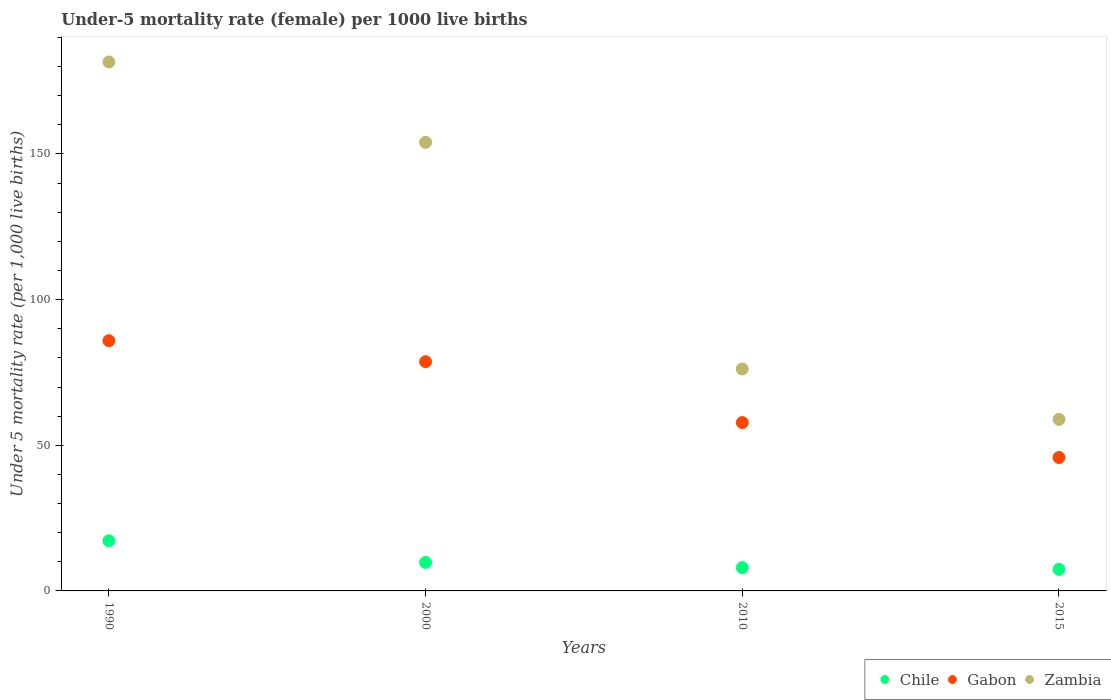How many different coloured dotlines are there?
Your answer should be very brief. 3. Is the number of dotlines equal to the number of legend labels?
Ensure brevity in your answer.  Yes. What is the under-five mortality rate in Gabon in 2015?
Make the answer very short. 45.8. Across all years, what is the maximum under-five mortality rate in Zambia?
Your response must be concise. 181.6. Across all years, what is the minimum under-five mortality rate in Chile?
Ensure brevity in your answer.  7.4. In which year was the under-five mortality rate in Zambia minimum?
Provide a succinct answer. 2015. What is the total under-five mortality rate in Gabon in the graph?
Provide a succinct answer. 268.2. What is the difference between the under-five mortality rate in Chile in 1990 and that in 2000?
Your answer should be compact. 7.4. What is the difference between the under-five mortality rate in Gabon in 2015 and the under-five mortality rate in Zambia in 1990?
Provide a short and direct response. -135.8. What is the average under-five mortality rate in Gabon per year?
Offer a very short reply. 67.05. In the year 2000, what is the difference between the under-five mortality rate in Chile and under-five mortality rate in Gabon?
Ensure brevity in your answer.  -68.9. What is the ratio of the under-five mortality rate in Chile in 2000 to that in 2015?
Ensure brevity in your answer.  1.32. Is the under-five mortality rate in Chile in 1990 less than that in 2015?
Ensure brevity in your answer.  No. What is the difference between the highest and the second highest under-five mortality rate in Gabon?
Make the answer very short. 7.2. What is the difference between the highest and the lowest under-five mortality rate in Zambia?
Provide a succinct answer. 122.7. Is the sum of the under-five mortality rate in Chile in 2000 and 2010 greater than the maximum under-five mortality rate in Gabon across all years?
Your answer should be compact. No. Is the under-five mortality rate in Zambia strictly less than the under-five mortality rate in Chile over the years?
Provide a succinct answer. No. What is the difference between two consecutive major ticks on the Y-axis?
Your answer should be compact. 50. Are the values on the major ticks of Y-axis written in scientific E-notation?
Provide a succinct answer. No. Does the graph contain any zero values?
Offer a very short reply. No. Does the graph contain grids?
Offer a very short reply. No. Where does the legend appear in the graph?
Give a very brief answer. Bottom right. How are the legend labels stacked?
Keep it short and to the point. Horizontal. What is the title of the graph?
Keep it short and to the point. Under-5 mortality rate (female) per 1000 live births. Does "Turkmenistan" appear as one of the legend labels in the graph?
Keep it short and to the point. No. What is the label or title of the Y-axis?
Your answer should be very brief. Under 5 mortality rate (per 1,0 live births). What is the Under 5 mortality rate (per 1,000 live births) of Gabon in 1990?
Offer a very short reply. 85.9. What is the Under 5 mortality rate (per 1,000 live births) in Zambia in 1990?
Provide a succinct answer. 181.6. What is the Under 5 mortality rate (per 1,000 live births) of Chile in 2000?
Ensure brevity in your answer.  9.8. What is the Under 5 mortality rate (per 1,000 live births) in Gabon in 2000?
Offer a very short reply. 78.7. What is the Under 5 mortality rate (per 1,000 live births) of Zambia in 2000?
Provide a short and direct response. 154. What is the Under 5 mortality rate (per 1,000 live births) of Gabon in 2010?
Your answer should be very brief. 57.8. What is the Under 5 mortality rate (per 1,000 live births) of Zambia in 2010?
Offer a very short reply. 76.2. What is the Under 5 mortality rate (per 1,000 live births) in Gabon in 2015?
Your answer should be very brief. 45.8. What is the Under 5 mortality rate (per 1,000 live births) of Zambia in 2015?
Give a very brief answer. 58.9. Across all years, what is the maximum Under 5 mortality rate (per 1,000 live births) of Gabon?
Ensure brevity in your answer.  85.9. Across all years, what is the maximum Under 5 mortality rate (per 1,000 live births) in Zambia?
Provide a succinct answer. 181.6. Across all years, what is the minimum Under 5 mortality rate (per 1,000 live births) of Chile?
Ensure brevity in your answer.  7.4. Across all years, what is the minimum Under 5 mortality rate (per 1,000 live births) of Gabon?
Give a very brief answer. 45.8. Across all years, what is the minimum Under 5 mortality rate (per 1,000 live births) in Zambia?
Offer a very short reply. 58.9. What is the total Under 5 mortality rate (per 1,000 live births) of Chile in the graph?
Give a very brief answer. 42.4. What is the total Under 5 mortality rate (per 1,000 live births) of Gabon in the graph?
Keep it short and to the point. 268.2. What is the total Under 5 mortality rate (per 1,000 live births) in Zambia in the graph?
Keep it short and to the point. 470.7. What is the difference between the Under 5 mortality rate (per 1,000 live births) in Chile in 1990 and that in 2000?
Provide a short and direct response. 7.4. What is the difference between the Under 5 mortality rate (per 1,000 live births) of Zambia in 1990 and that in 2000?
Provide a succinct answer. 27.6. What is the difference between the Under 5 mortality rate (per 1,000 live births) in Gabon in 1990 and that in 2010?
Make the answer very short. 28.1. What is the difference between the Under 5 mortality rate (per 1,000 live births) in Zambia in 1990 and that in 2010?
Ensure brevity in your answer.  105.4. What is the difference between the Under 5 mortality rate (per 1,000 live births) of Chile in 1990 and that in 2015?
Your answer should be compact. 9.8. What is the difference between the Under 5 mortality rate (per 1,000 live births) of Gabon in 1990 and that in 2015?
Your answer should be very brief. 40.1. What is the difference between the Under 5 mortality rate (per 1,000 live births) in Zambia in 1990 and that in 2015?
Give a very brief answer. 122.7. What is the difference between the Under 5 mortality rate (per 1,000 live births) of Gabon in 2000 and that in 2010?
Keep it short and to the point. 20.9. What is the difference between the Under 5 mortality rate (per 1,000 live births) in Zambia in 2000 and that in 2010?
Offer a very short reply. 77.8. What is the difference between the Under 5 mortality rate (per 1,000 live births) in Chile in 2000 and that in 2015?
Your answer should be very brief. 2.4. What is the difference between the Under 5 mortality rate (per 1,000 live births) of Gabon in 2000 and that in 2015?
Provide a succinct answer. 32.9. What is the difference between the Under 5 mortality rate (per 1,000 live births) in Zambia in 2000 and that in 2015?
Your answer should be compact. 95.1. What is the difference between the Under 5 mortality rate (per 1,000 live births) of Gabon in 2010 and that in 2015?
Offer a very short reply. 12. What is the difference between the Under 5 mortality rate (per 1,000 live births) in Zambia in 2010 and that in 2015?
Make the answer very short. 17.3. What is the difference between the Under 5 mortality rate (per 1,000 live births) in Chile in 1990 and the Under 5 mortality rate (per 1,000 live births) in Gabon in 2000?
Your answer should be compact. -61.5. What is the difference between the Under 5 mortality rate (per 1,000 live births) of Chile in 1990 and the Under 5 mortality rate (per 1,000 live births) of Zambia in 2000?
Ensure brevity in your answer.  -136.8. What is the difference between the Under 5 mortality rate (per 1,000 live births) of Gabon in 1990 and the Under 5 mortality rate (per 1,000 live births) of Zambia in 2000?
Offer a very short reply. -68.1. What is the difference between the Under 5 mortality rate (per 1,000 live births) of Chile in 1990 and the Under 5 mortality rate (per 1,000 live births) of Gabon in 2010?
Provide a short and direct response. -40.6. What is the difference between the Under 5 mortality rate (per 1,000 live births) of Chile in 1990 and the Under 5 mortality rate (per 1,000 live births) of Zambia in 2010?
Offer a very short reply. -59. What is the difference between the Under 5 mortality rate (per 1,000 live births) of Gabon in 1990 and the Under 5 mortality rate (per 1,000 live births) of Zambia in 2010?
Make the answer very short. 9.7. What is the difference between the Under 5 mortality rate (per 1,000 live births) in Chile in 1990 and the Under 5 mortality rate (per 1,000 live births) in Gabon in 2015?
Make the answer very short. -28.6. What is the difference between the Under 5 mortality rate (per 1,000 live births) of Chile in 1990 and the Under 5 mortality rate (per 1,000 live births) of Zambia in 2015?
Offer a very short reply. -41.7. What is the difference between the Under 5 mortality rate (per 1,000 live births) in Chile in 2000 and the Under 5 mortality rate (per 1,000 live births) in Gabon in 2010?
Keep it short and to the point. -48. What is the difference between the Under 5 mortality rate (per 1,000 live births) of Chile in 2000 and the Under 5 mortality rate (per 1,000 live births) of Zambia in 2010?
Make the answer very short. -66.4. What is the difference between the Under 5 mortality rate (per 1,000 live births) of Chile in 2000 and the Under 5 mortality rate (per 1,000 live births) of Gabon in 2015?
Offer a very short reply. -36. What is the difference between the Under 5 mortality rate (per 1,000 live births) in Chile in 2000 and the Under 5 mortality rate (per 1,000 live births) in Zambia in 2015?
Offer a very short reply. -49.1. What is the difference between the Under 5 mortality rate (per 1,000 live births) of Gabon in 2000 and the Under 5 mortality rate (per 1,000 live births) of Zambia in 2015?
Ensure brevity in your answer.  19.8. What is the difference between the Under 5 mortality rate (per 1,000 live births) of Chile in 2010 and the Under 5 mortality rate (per 1,000 live births) of Gabon in 2015?
Offer a very short reply. -37.8. What is the difference between the Under 5 mortality rate (per 1,000 live births) of Chile in 2010 and the Under 5 mortality rate (per 1,000 live births) of Zambia in 2015?
Ensure brevity in your answer.  -50.9. What is the difference between the Under 5 mortality rate (per 1,000 live births) in Gabon in 2010 and the Under 5 mortality rate (per 1,000 live births) in Zambia in 2015?
Offer a very short reply. -1.1. What is the average Under 5 mortality rate (per 1,000 live births) of Chile per year?
Make the answer very short. 10.6. What is the average Under 5 mortality rate (per 1,000 live births) in Gabon per year?
Provide a succinct answer. 67.05. What is the average Under 5 mortality rate (per 1,000 live births) of Zambia per year?
Your answer should be compact. 117.67. In the year 1990, what is the difference between the Under 5 mortality rate (per 1,000 live births) of Chile and Under 5 mortality rate (per 1,000 live births) of Gabon?
Provide a succinct answer. -68.7. In the year 1990, what is the difference between the Under 5 mortality rate (per 1,000 live births) of Chile and Under 5 mortality rate (per 1,000 live births) of Zambia?
Ensure brevity in your answer.  -164.4. In the year 1990, what is the difference between the Under 5 mortality rate (per 1,000 live births) of Gabon and Under 5 mortality rate (per 1,000 live births) of Zambia?
Provide a short and direct response. -95.7. In the year 2000, what is the difference between the Under 5 mortality rate (per 1,000 live births) of Chile and Under 5 mortality rate (per 1,000 live births) of Gabon?
Your response must be concise. -68.9. In the year 2000, what is the difference between the Under 5 mortality rate (per 1,000 live births) of Chile and Under 5 mortality rate (per 1,000 live births) of Zambia?
Your response must be concise. -144.2. In the year 2000, what is the difference between the Under 5 mortality rate (per 1,000 live births) in Gabon and Under 5 mortality rate (per 1,000 live births) in Zambia?
Offer a terse response. -75.3. In the year 2010, what is the difference between the Under 5 mortality rate (per 1,000 live births) in Chile and Under 5 mortality rate (per 1,000 live births) in Gabon?
Your answer should be compact. -49.8. In the year 2010, what is the difference between the Under 5 mortality rate (per 1,000 live births) of Chile and Under 5 mortality rate (per 1,000 live births) of Zambia?
Your response must be concise. -68.2. In the year 2010, what is the difference between the Under 5 mortality rate (per 1,000 live births) in Gabon and Under 5 mortality rate (per 1,000 live births) in Zambia?
Your answer should be very brief. -18.4. In the year 2015, what is the difference between the Under 5 mortality rate (per 1,000 live births) in Chile and Under 5 mortality rate (per 1,000 live births) in Gabon?
Give a very brief answer. -38.4. In the year 2015, what is the difference between the Under 5 mortality rate (per 1,000 live births) of Chile and Under 5 mortality rate (per 1,000 live births) of Zambia?
Your answer should be compact. -51.5. In the year 2015, what is the difference between the Under 5 mortality rate (per 1,000 live births) in Gabon and Under 5 mortality rate (per 1,000 live births) in Zambia?
Offer a terse response. -13.1. What is the ratio of the Under 5 mortality rate (per 1,000 live births) in Chile in 1990 to that in 2000?
Your answer should be very brief. 1.76. What is the ratio of the Under 5 mortality rate (per 1,000 live births) in Gabon in 1990 to that in 2000?
Offer a very short reply. 1.09. What is the ratio of the Under 5 mortality rate (per 1,000 live births) of Zambia in 1990 to that in 2000?
Keep it short and to the point. 1.18. What is the ratio of the Under 5 mortality rate (per 1,000 live births) in Chile in 1990 to that in 2010?
Give a very brief answer. 2.15. What is the ratio of the Under 5 mortality rate (per 1,000 live births) of Gabon in 1990 to that in 2010?
Give a very brief answer. 1.49. What is the ratio of the Under 5 mortality rate (per 1,000 live births) in Zambia in 1990 to that in 2010?
Keep it short and to the point. 2.38. What is the ratio of the Under 5 mortality rate (per 1,000 live births) in Chile in 1990 to that in 2015?
Provide a short and direct response. 2.32. What is the ratio of the Under 5 mortality rate (per 1,000 live births) of Gabon in 1990 to that in 2015?
Offer a very short reply. 1.88. What is the ratio of the Under 5 mortality rate (per 1,000 live births) in Zambia in 1990 to that in 2015?
Your response must be concise. 3.08. What is the ratio of the Under 5 mortality rate (per 1,000 live births) in Chile in 2000 to that in 2010?
Ensure brevity in your answer.  1.23. What is the ratio of the Under 5 mortality rate (per 1,000 live births) in Gabon in 2000 to that in 2010?
Offer a very short reply. 1.36. What is the ratio of the Under 5 mortality rate (per 1,000 live births) in Zambia in 2000 to that in 2010?
Give a very brief answer. 2.02. What is the ratio of the Under 5 mortality rate (per 1,000 live births) of Chile in 2000 to that in 2015?
Your answer should be compact. 1.32. What is the ratio of the Under 5 mortality rate (per 1,000 live births) of Gabon in 2000 to that in 2015?
Your answer should be very brief. 1.72. What is the ratio of the Under 5 mortality rate (per 1,000 live births) in Zambia in 2000 to that in 2015?
Your answer should be very brief. 2.61. What is the ratio of the Under 5 mortality rate (per 1,000 live births) in Chile in 2010 to that in 2015?
Provide a succinct answer. 1.08. What is the ratio of the Under 5 mortality rate (per 1,000 live births) in Gabon in 2010 to that in 2015?
Offer a terse response. 1.26. What is the ratio of the Under 5 mortality rate (per 1,000 live births) of Zambia in 2010 to that in 2015?
Provide a succinct answer. 1.29. What is the difference between the highest and the second highest Under 5 mortality rate (per 1,000 live births) of Gabon?
Give a very brief answer. 7.2. What is the difference between the highest and the second highest Under 5 mortality rate (per 1,000 live births) in Zambia?
Your answer should be very brief. 27.6. What is the difference between the highest and the lowest Under 5 mortality rate (per 1,000 live births) of Chile?
Make the answer very short. 9.8. What is the difference between the highest and the lowest Under 5 mortality rate (per 1,000 live births) in Gabon?
Provide a succinct answer. 40.1. What is the difference between the highest and the lowest Under 5 mortality rate (per 1,000 live births) in Zambia?
Offer a very short reply. 122.7. 